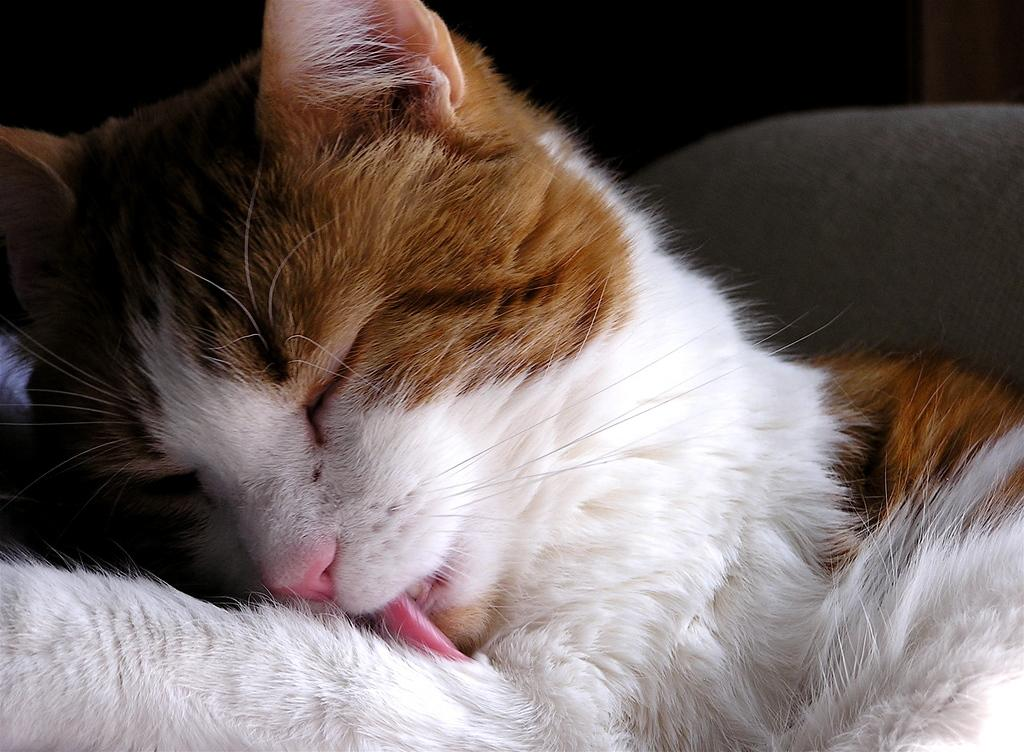What type of animal is in the picture? There is a cat in the picture. Can you describe the cat's fur? The cat has white and brown fur. What can be seen in the background of the image? The backdrop of the image is dark. What type of riddle does the cat solve in the image? There is no riddle present in the image, and the cat is not solving any riddles. 